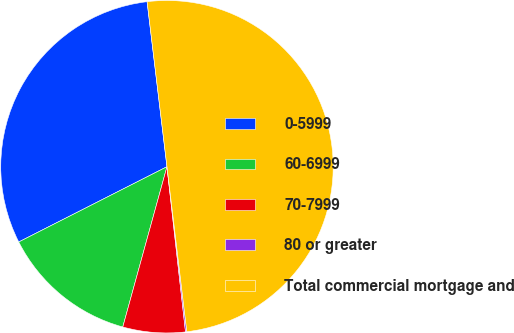Convert chart. <chart><loc_0><loc_0><loc_500><loc_500><pie_chart><fcel>0-5999<fcel>60-6999<fcel>70-7999<fcel>80 or greater<fcel>Total commercial mortgage and<nl><fcel>30.57%<fcel>13.24%<fcel>6.06%<fcel>0.13%<fcel>50.0%<nl></chart> 